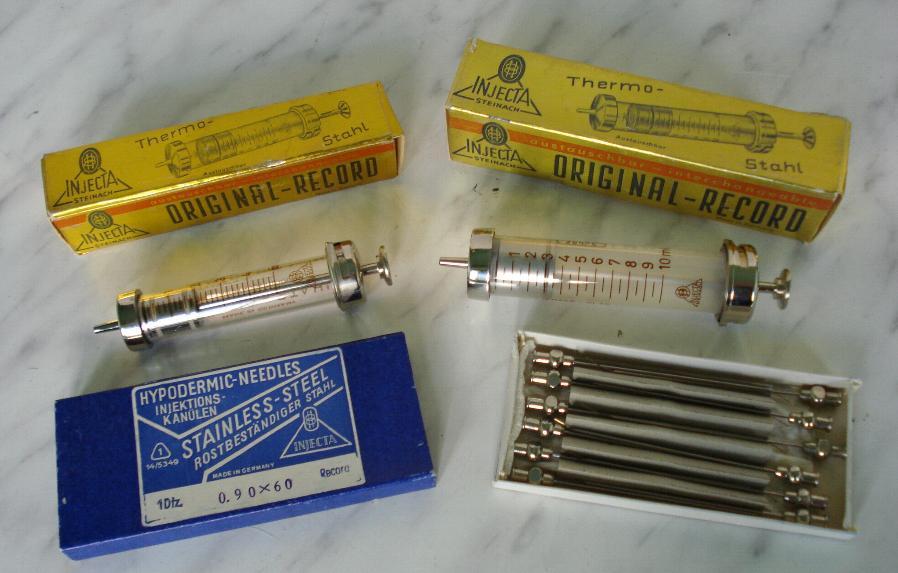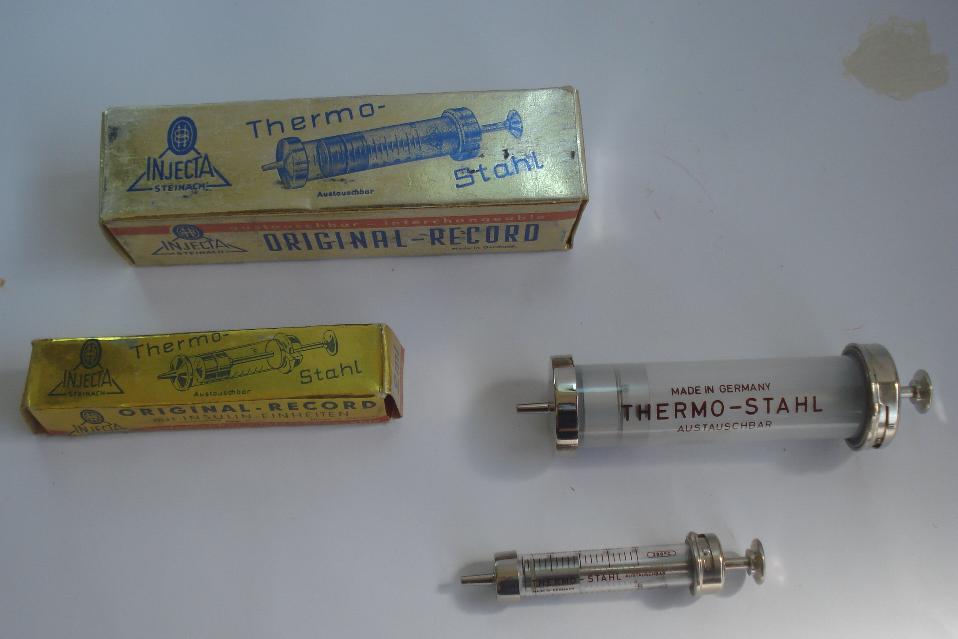The first image is the image on the left, the second image is the image on the right. For the images shown, is this caption "there are at least 3 syringes" true? Answer yes or no. Yes. The first image is the image on the left, the second image is the image on the right. Analyze the images presented: Is the assertion "There are no more than two syringes in total." valid? Answer yes or no. No. 